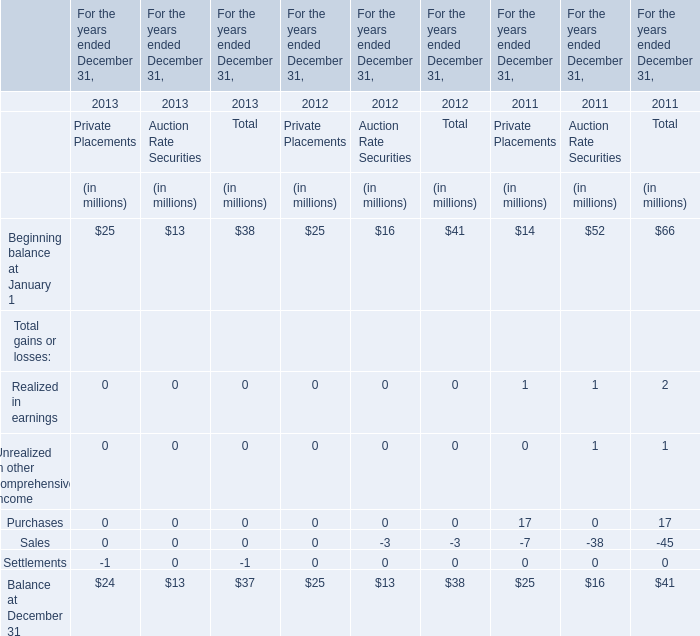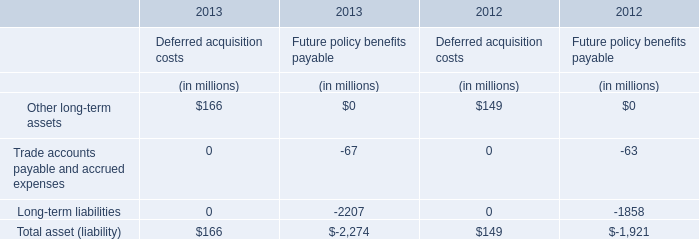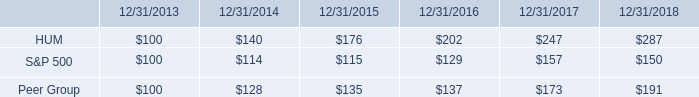In what year is Beginning balance at January 1 of Auction Rate Securities the least? 
Answer: 2013. 